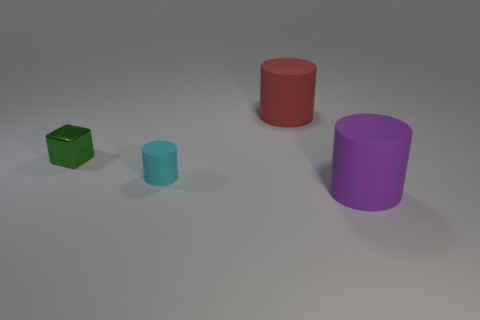How many things are either small cubes behind the tiny cyan object or large rubber things in front of the green object?
Offer a terse response. 2. How many other objects are there of the same shape as the small metallic thing?
Offer a terse response. 0. There is a large rubber object that is to the left of the big purple matte thing; does it have the same color as the block?
Your answer should be compact. No. How many other things are there of the same size as the block?
Your answer should be very brief. 1. Is the material of the cyan cylinder the same as the large purple object?
Offer a terse response. Yes. There is a cylinder that is left of the big rubber thing to the left of the purple cylinder; what is its color?
Your response must be concise. Cyan. The other purple object that is the same shape as the small matte object is what size?
Your answer should be compact. Large. Does the tiny cylinder have the same color as the shiny thing?
Offer a very short reply. No. There is a large object in front of the matte cylinder on the left side of the red cylinder; what number of large purple things are right of it?
Ensure brevity in your answer.  0. Are there more tiny green spheres than red cylinders?
Your answer should be very brief. No. 